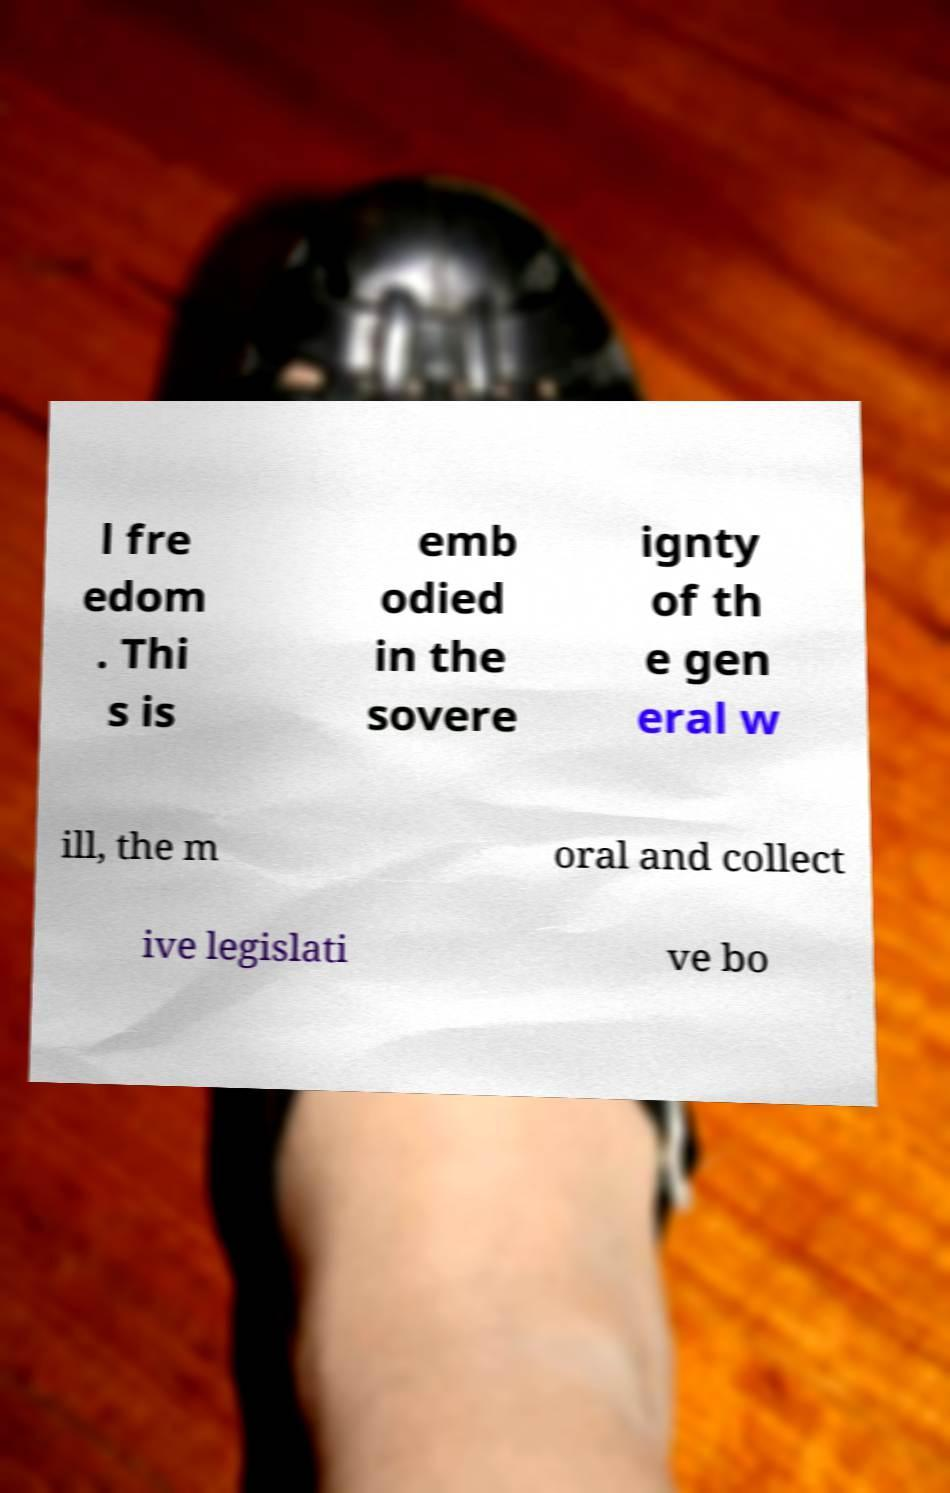I need the written content from this picture converted into text. Can you do that? l fre edom . Thi s is emb odied in the sovere ignty of th e gen eral w ill, the m oral and collect ive legislati ve bo 